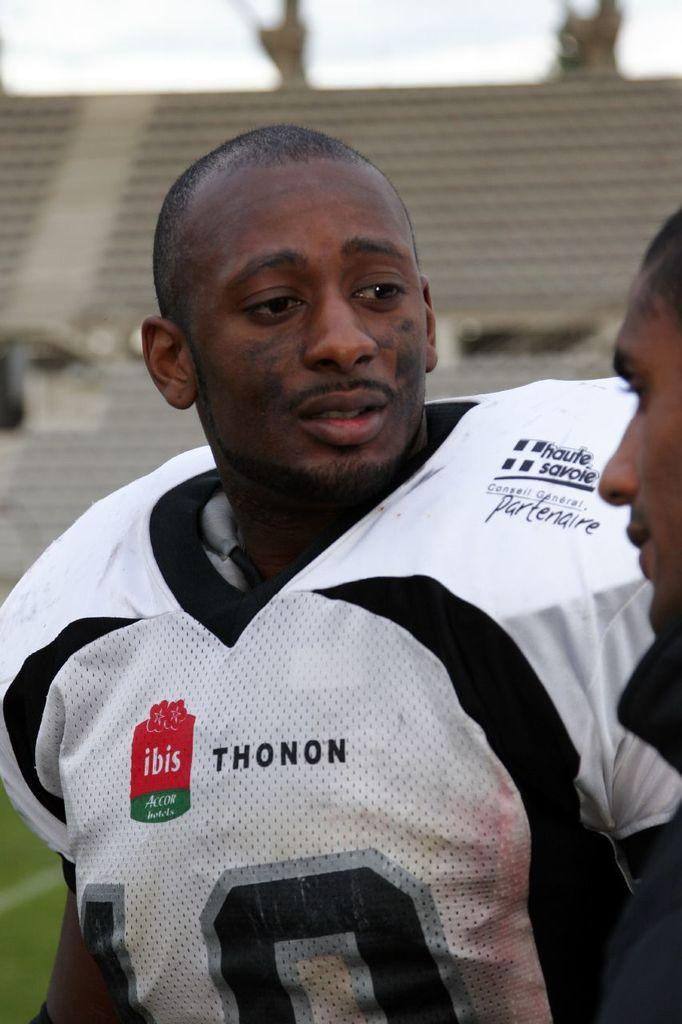Provide a one-sentence caption for the provided image. A football player in a white jersey that has advertisements for Thonon and ibis on it. 